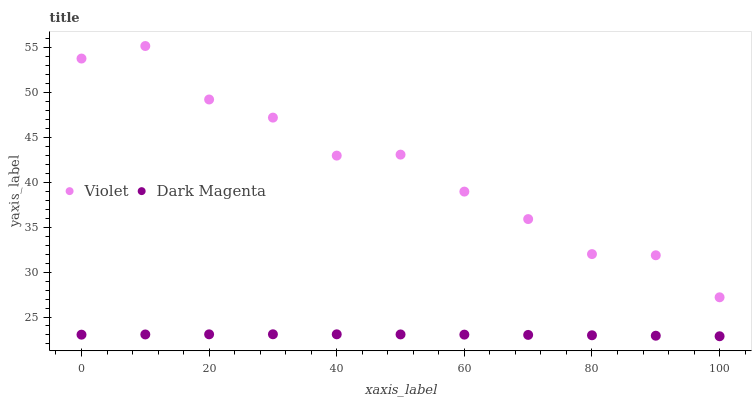Does Dark Magenta have the minimum area under the curve?
Answer yes or no. Yes. Does Violet have the maximum area under the curve?
Answer yes or no. Yes. Does Violet have the minimum area under the curve?
Answer yes or no. No. Is Dark Magenta the smoothest?
Answer yes or no. Yes. Is Violet the roughest?
Answer yes or no. Yes. Is Violet the smoothest?
Answer yes or no. No. Does Dark Magenta have the lowest value?
Answer yes or no. Yes. Does Violet have the lowest value?
Answer yes or no. No. Does Violet have the highest value?
Answer yes or no. Yes. Is Dark Magenta less than Violet?
Answer yes or no. Yes. Is Violet greater than Dark Magenta?
Answer yes or no. Yes. Does Dark Magenta intersect Violet?
Answer yes or no. No. 